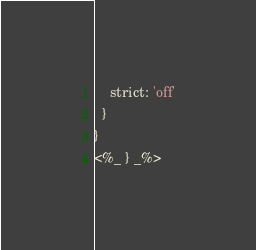Convert code to text. <code><loc_0><loc_0><loc_500><loc_500><_JavaScript_>    strict: 'off'
  }
}
<%_ } _%>
</code> 